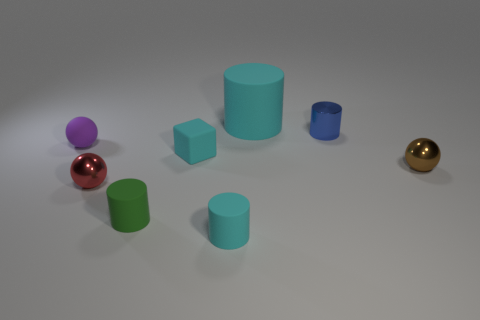There is a tiny object behind the tiny matte sphere; what color is it?
Your answer should be very brief. Blue. What number of things are matte things behind the blue object or tiny shiny balls on the right side of the red object?
Provide a succinct answer. 2. What number of other metallic objects are the same shape as the small brown shiny thing?
Your answer should be compact. 1. What color is the block that is the same size as the matte ball?
Your answer should be very brief. Cyan. There is a object that is to the left of the metal sphere that is on the left side of the cyan cylinder behind the tiny green cylinder; what is its color?
Give a very brief answer. Purple. There is a red ball; is its size the same as the matte cylinder that is behind the tiny green object?
Ensure brevity in your answer.  No. What number of things are either large red shiny cylinders or metal objects?
Your answer should be very brief. 3. Is there a small cyan object made of the same material as the tiny cube?
Provide a short and direct response. Yes. There is a block that is the same color as the big matte thing; what is its size?
Offer a terse response. Small. The cylinder that is in front of the green rubber thing that is in front of the big cyan cylinder is what color?
Provide a short and direct response. Cyan. 